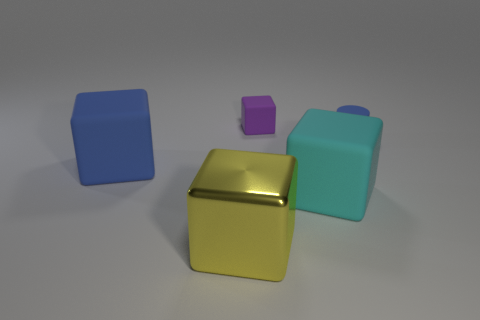What number of things are either rubber blocks or small cylinders?
Offer a very short reply. 4. Is there another rubber cylinder of the same color as the small cylinder?
Provide a short and direct response. No. Are there fewer big rubber things than brown cylinders?
Give a very brief answer. No. What number of things are yellow blocks or blocks that are in front of the tiny purple rubber cube?
Your response must be concise. 3. Is there another tiny purple block that has the same material as the tiny block?
Your response must be concise. No. What is the material of the other object that is the same size as the purple object?
Ensure brevity in your answer.  Rubber. What material is the blue object to the right of the blue object that is on the left side of the big cyan rubber object?
Your answer should be very brief. Rubber. Do the matte thing that is in front of the blue block and the large blue thing have the same shape?
Offer a very short reply. Yes. What color is the cylinder that is made of the same material as the small cube?
Make the answer very short. Blue. What material is the blue object that is on the left side of the purple cube?
Provide a succinct answer. Rubber. 